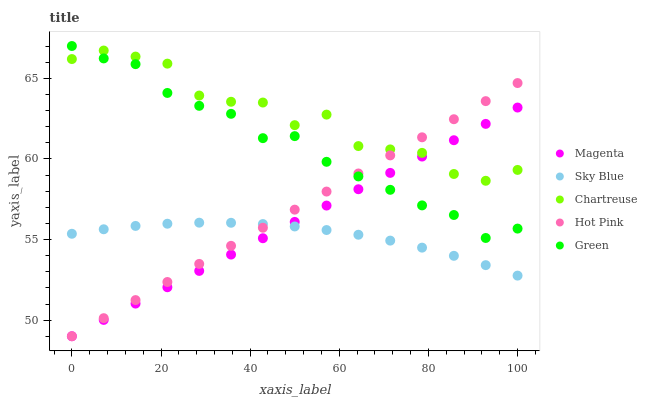Does Sky Blue have the minimum area under the curve?
Answer yes or no. Yes. Does Chartreuse have the maximum area under the curve?
Answer yes or no. Yes. Does Magenta have the minimum area under the curve?
Answer yes or no. No. Does Magenta have the maximum area under the curve?
Answer yes or no. No. Is Hot Pink the smoothest?
Answer yes or no. Yes. Is Chartreuse the roughest?
Answer yes or no. Yes. Is Magenta the smoothest?
Answer yes or no. No. Is Magenta the roughest?
Answer yes or no. No. Does Magenta have the lowest value?
Answer yes or no. Yes. Does Green have the lowest value?
Answer yes or no. No. Does Green have the highest value?
Answer yes or no. Yes. Does Magenta have the highest value?
Answer yes or no. No. Is Sky Blue less than Green?
Answer yes or no. Yes. Is Chartreuse greater than Sky Blue?
Answer yes or no. Yes. Does Magenta intersect Green?
Answer yes or no. Yes. Is Magenta less than Green?
Answer yes or no. No. Is Magenta greater than Green?
Answer yes or no. No. Does Sky Blue intersect Green?
Answer yes or no. No. 